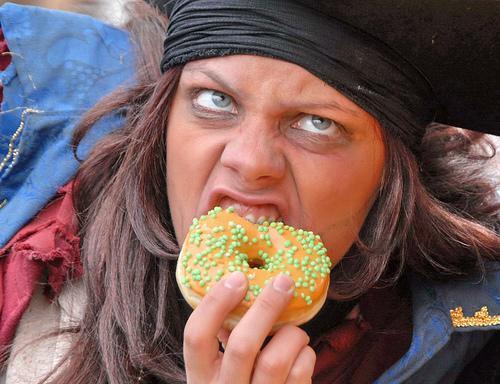How many people are shown?
Give a very brief answer. 1. How many fingers are on top of the donut?
Give a very brief answer. 2. 